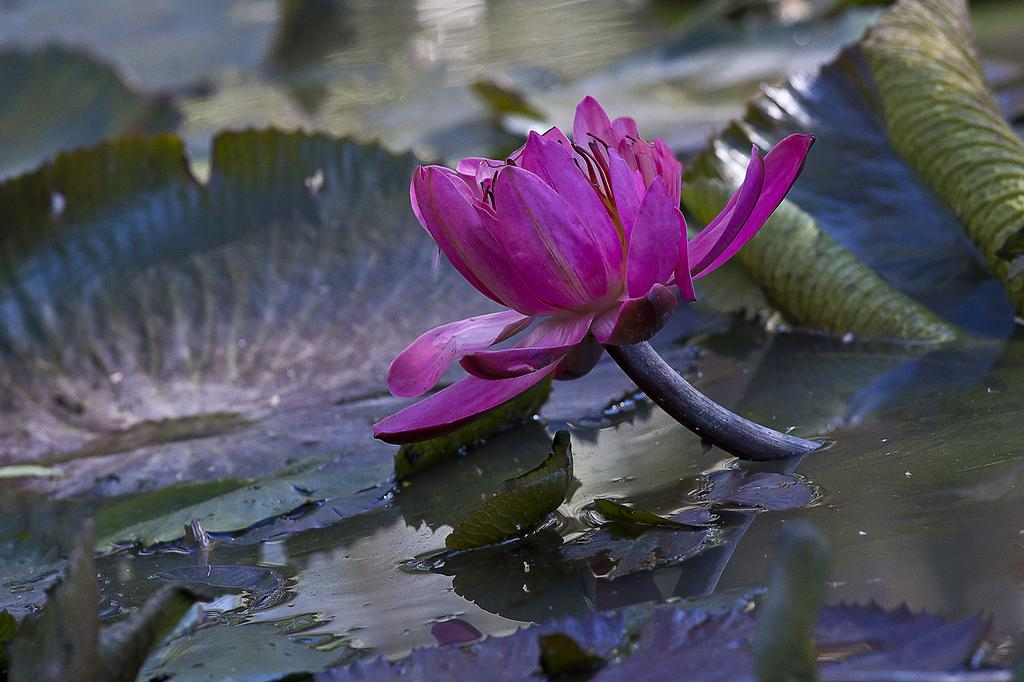What type of flower is in the image? There is a pink lotus in the image. What else can be seen in the image besides the flower? There are leaves and a water body in the image. How is the background of the image depicted? The background of the image is blurred. How many pieces of cheese can be seen in the image? There is no cheese present in the image. What is the bit size of the lotus in the image? The lotus is not depicted as having a bit size, as it is a full flower in the image. 